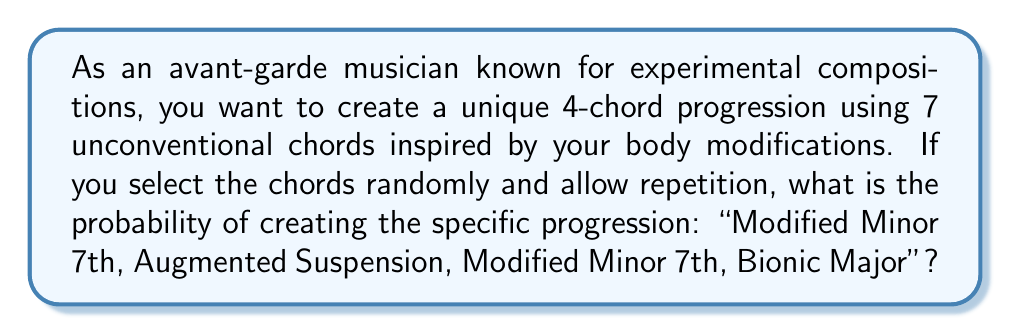Give your solution to this math problem. Let's approach this step-by-step:

1) We have 7 unconventional chords to choose from for each position in the 4-chord progression.

2) For each position, we have 7 choices, and we allow repetition. This means the choices for each position are independent.

3) We can model this as a sequence of 4 independent events, where each event has 7 possible outcomes.

4) The probability of choosing a specific chord for any position is $\frac{1}{7}$.

5) To calculate the probability of the entire specific progression, we multiply the probabilities of each individual chord selection:

   $$P(\text{specific progression}) = \frac{1}{7} \times \frac{1}{7} \times \frac{1}{7} \times \frac{1}{7}$$

6) This can be written as:

   $$P(\text{specific progression}) = \left(\frac{1}{7}\right)^4$$

7) Calculating this:

   $$P(\text{specific progression}) = \frac{1}{2401}$$

Therefore, the probability of randomly creating this specific 4-chord progression is $\frac{1}{2401}$.
Answer: $\frac{1}{2401}$ 